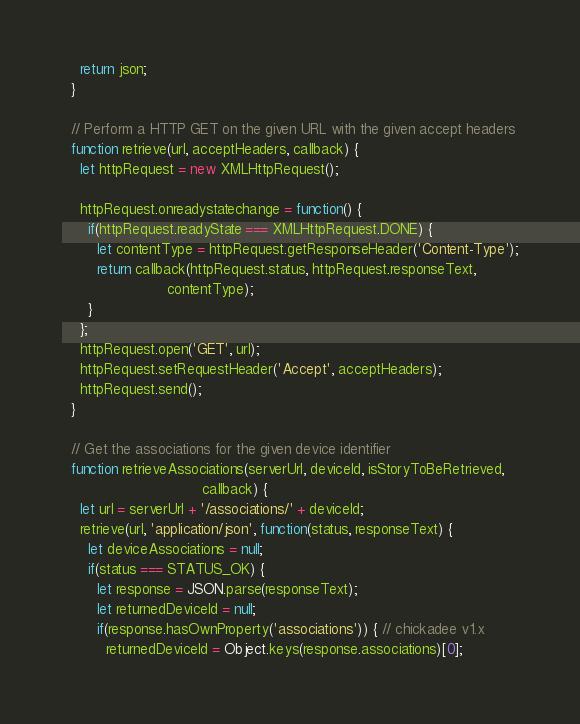Convert code to text. <code><loc_0><loc_0><loc_500><loc_500><_JavaScript_>    return json;
  }

  // Perform a HTTP GET on the given URL with the given accept headers
  function retrieve(url, acceptHeaders, callback) {
    let httpRequest = new XMLHttpRequest();

    httpRequest.onreadystatechange = function() {
      if(httpRequest.readyState === XMLHttpRequest.DONE) {
        let contentType = httpRequest.getResponseHeader('Content-Type');
        return callback(httpRequest.status, httpRequest.responseText,
                        contentType);
      }
    };
    httpRequest.open('GET', url);
    httpRequest.setRequestHeader('Accept', acceptHeaders);
    httpRequest.send();
  }

  // Get the associations for the given device identifier
  function retrieveAssociations(serverUrl, deviceId, isStoryToBeRetrieved,
                                callback) {
    let url = serverUrl + '/associations/' + deviceId;
    retrieve(url, 'application/json', function(status, responseText) {
      let deviceAssociations = null;
      if(status === STATUS_OK) {
        let response = JSON.parse(responseText);
        let returnedDeviceId = null;
        if(response.hasOwnProperty('associations')) { // chickadee v1.x
          returnedDeviceId = Object.keys(response.associations)[0];</code> 